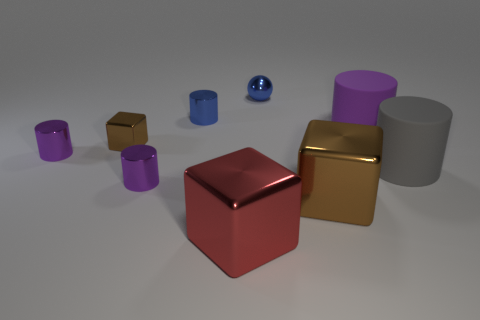The big metallic block behind the metal thing that is in front of the big brown shiny thing is what color? The larger metallic block positioned behind the smaller metal object, which is in turn in front of the highly reflective brown object, appears to be gold in color. 